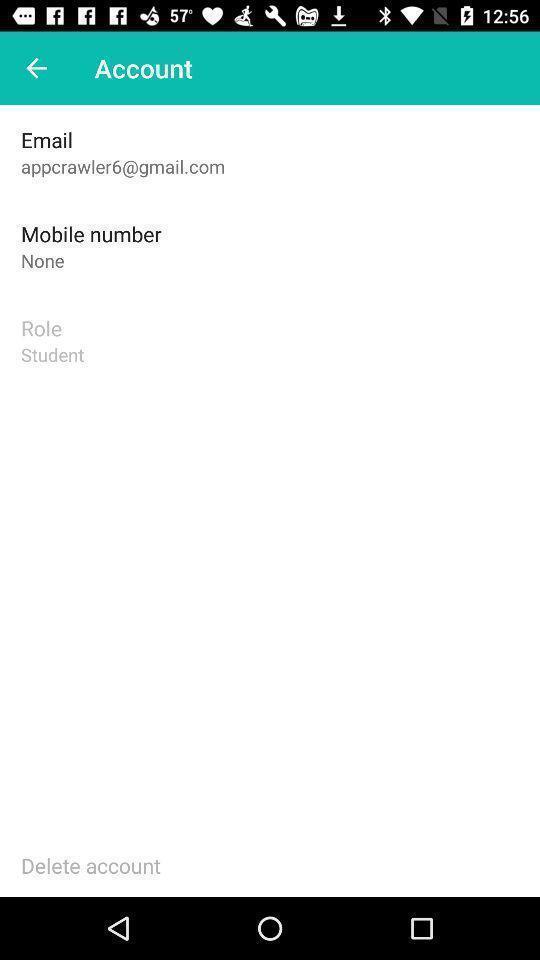Provide a textual representation of this image. Screen showing details in account. 